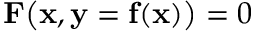<formula> <loc_0><loc_0><loc_500><loc_500>F \left ( x , y = f ( x ) \right ) = 0</formula> 